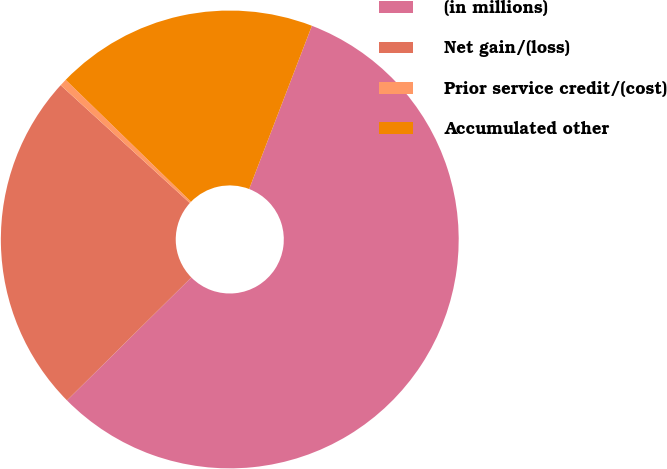<chart> <loc_0><loc_0><loc_500><loc_500><pie_chart><fcel>(in millions)<fcel>Net gain/(loss)<fcel>Prior service credit/(cost)<fcel>Accumulated other<nl><fcel>56.75%<fcel>24.18%<fcel>0.51%<fcel>18.56%<nl></chart> 